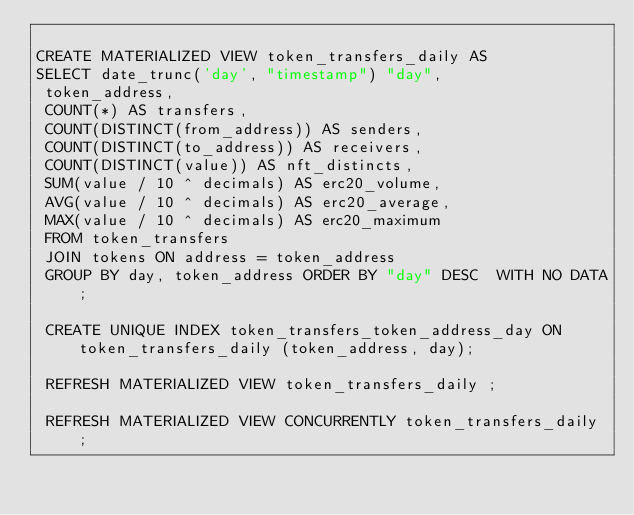<code> <loc_0><loc_0><loc_500><loc_500><_SQL_>
CREATE MATERIALIZED VIEW token_transfers_daily AS
SELECT date_trunc('day', "timestamp") "day",
 token_address,
 COUNT(*) AS transfers,
 COUNT(DISTINCT(from_address)) AS senders,
 COUNT(DISTINCT(to_address)) AS receivers,
 COUNT(DISTINCT(value)) AS nft_distincts,
 SUM(value / 10 ^ decimals) AS erc20_volume,
 AVG(value / 10 ^ decimals) AS erc20_average,
 MAX(value / 10 ^ decimals) AS erc20_maximum
 FROM token_transfers
 JOIN tokens ON address = token_address
 GROUP BY day, token_address ORDER BY "day" DESC  WITH NO DATA;

 CREATE UNIQUE INDEX token_transfers_token_address_day ON token_transfers_daily (token_address, day);

 REFRESH MATERIALIZED VIEW token_transfers_daily ;

 REFRESH MATERIALIZED VIEW CONCURRENTLY token_transfers_daily ;
</code> 